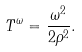<formula> <loc_0><loc_0><loc_500><loc_500>T ^ { \omega } = \frac { \omega ^ { 2 } } { 2 \rho ^ { 2 } } .</formula> 